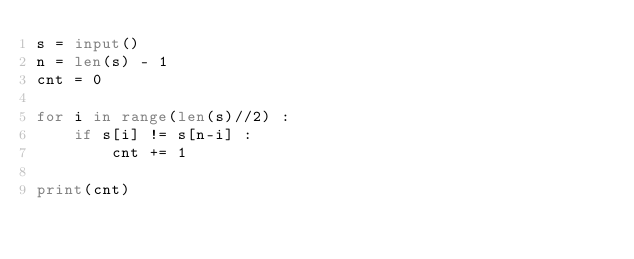Convert code to text. <code><loc_0><loc_0><loc_500><loc_500><_Python_>s = input()
n = len(s) - 1
cnt = 0

for i in range(len(s)//2) :
    if s[i] != s[n-i] :
        cnt += 1

print(cnt)
</code> 